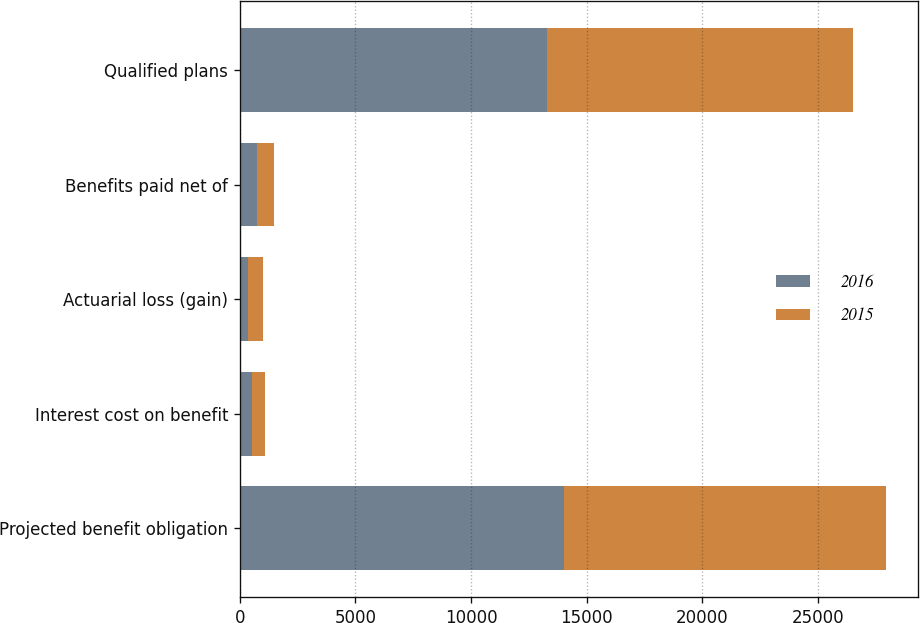<chart> <loc_0><loc_0><loc_500><loc_500><stacked_bar_chart><ecel><fcel>Projected benefit obligation<fcel>Interest cost on benefit<fcel>Actuarial loss (gain)<fcel>Benefits paid net of<fcel>Qualified plans<nl><fcel>2016<fcel>14000<fcel>520<fcel>351<fcel>722<fcel>13271<nl><fcel>2015<fcel>13943<fcel>553<fcel>649<fcel>751<fcel>13231<nl></chart> 